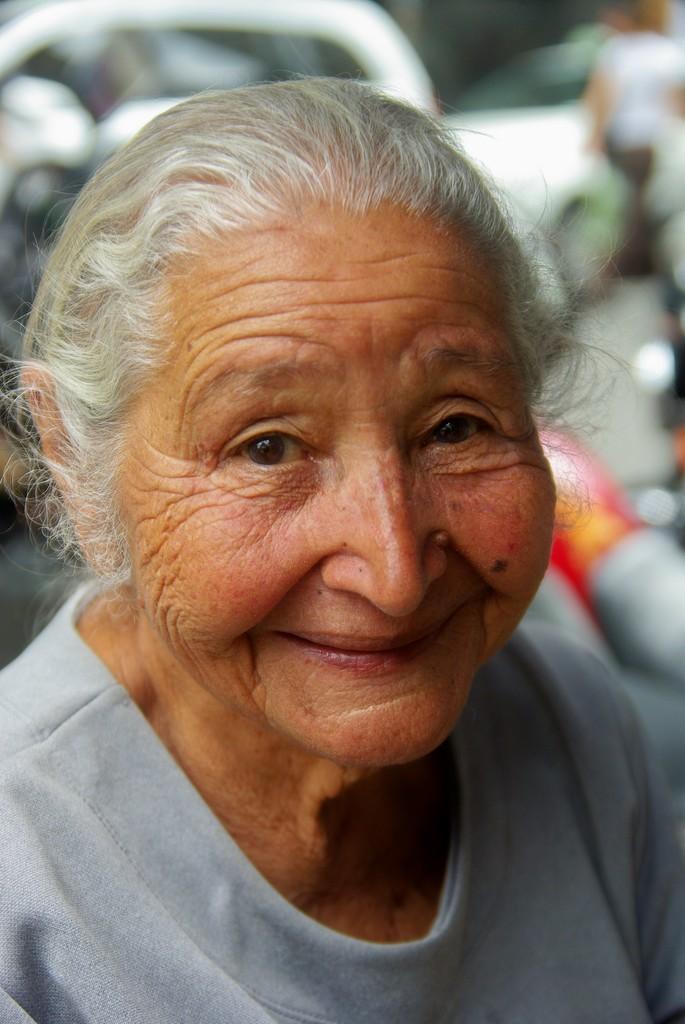Can you describe this image briefly? The old lady in front of the picture wearing a grey t-shirt is smiling. In the background, we see vehicles moving on the road and it is blurred in the background. 